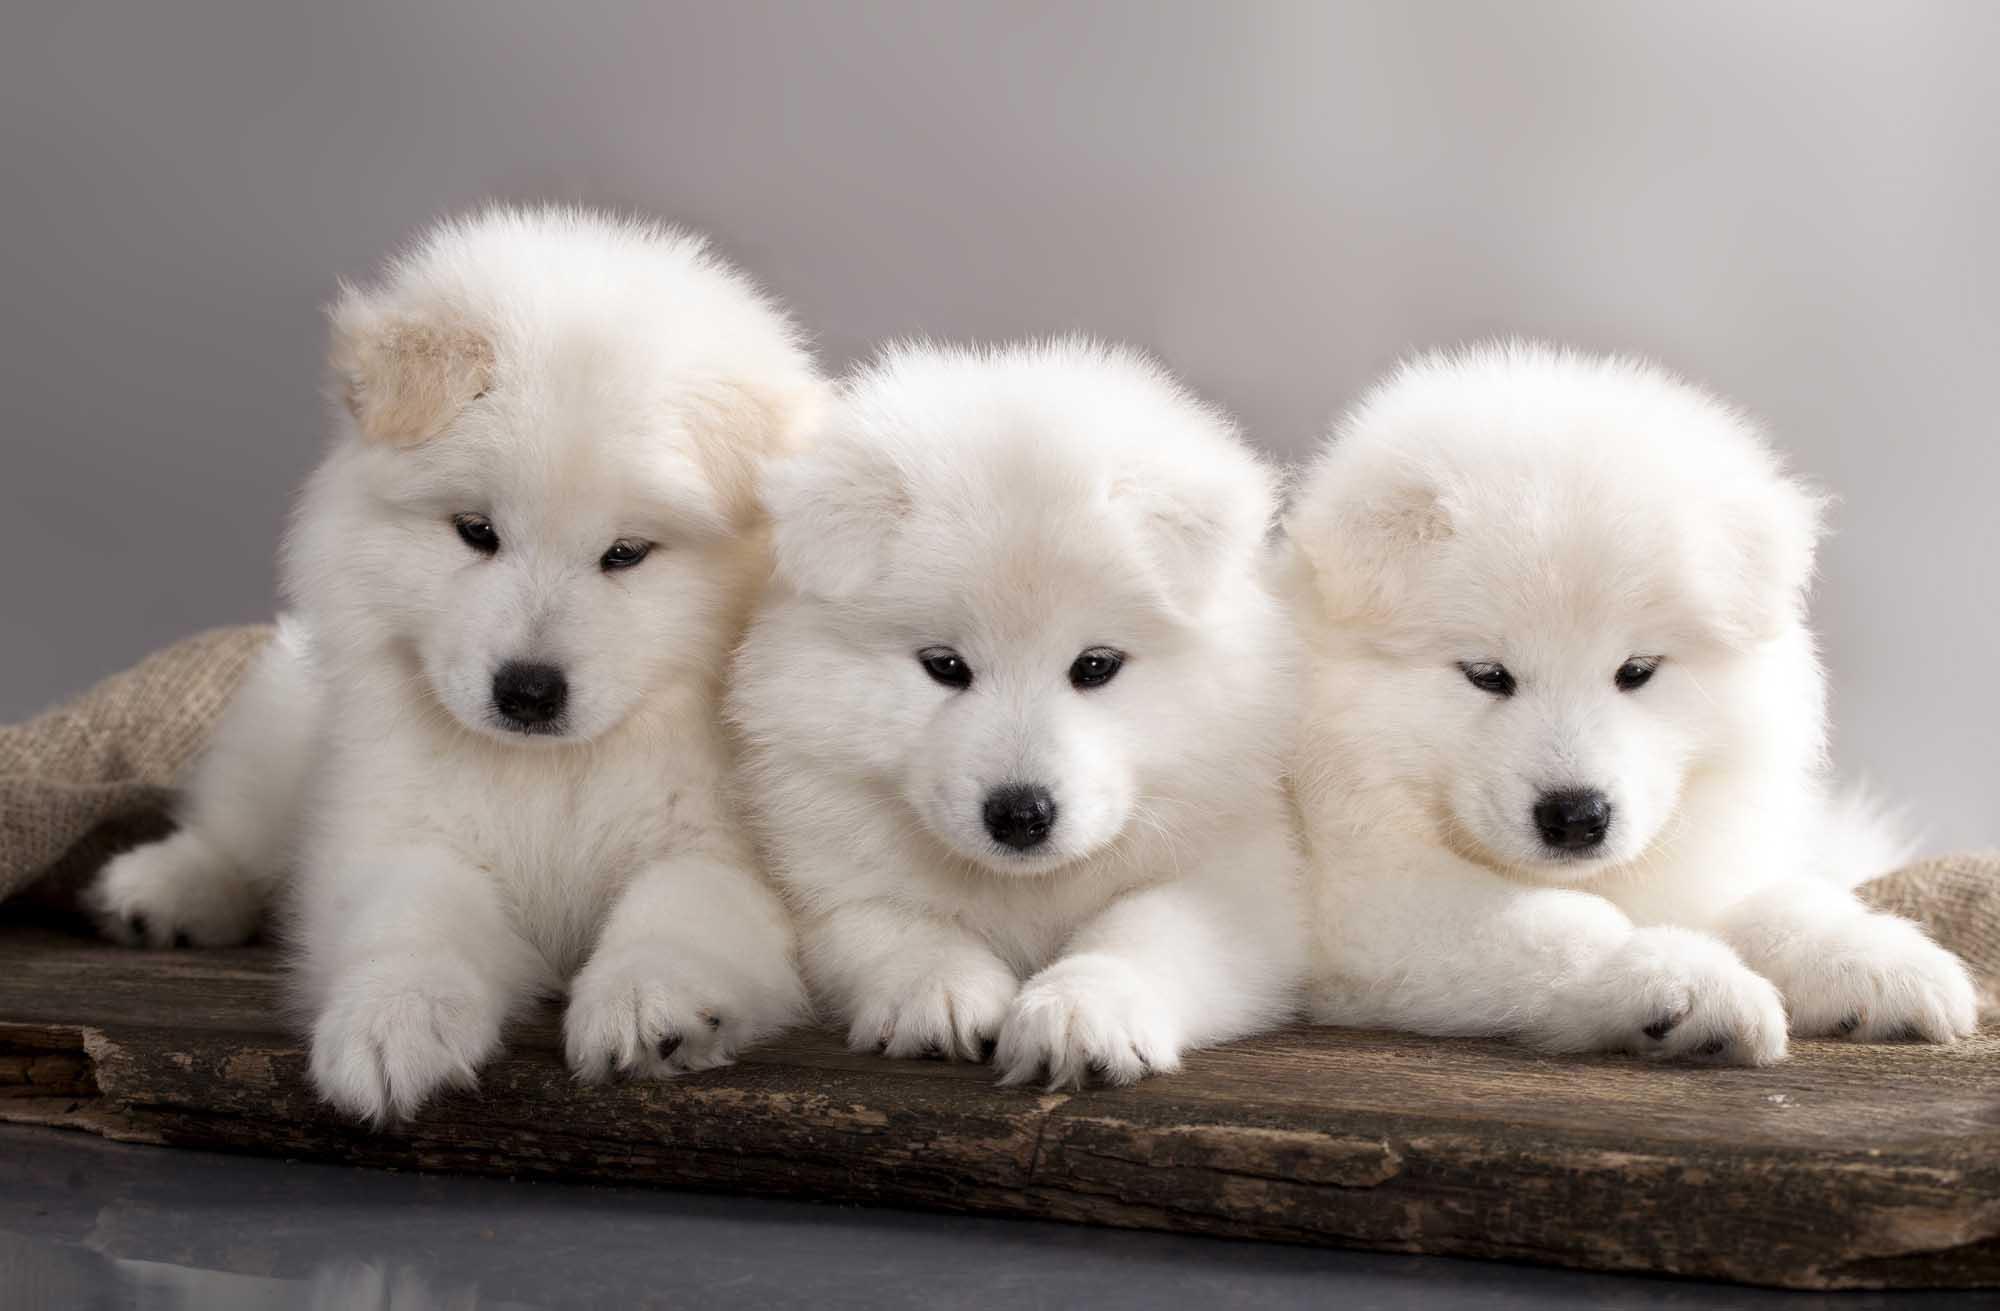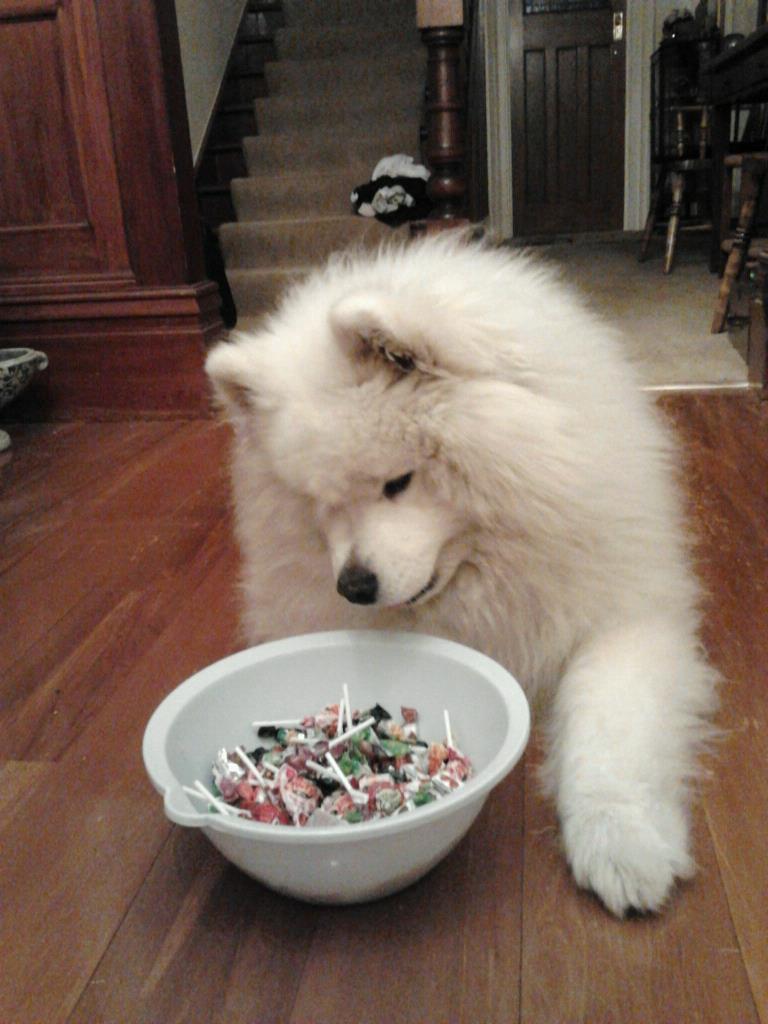The first image is the image on the left, the second image is the image on the right. For the images shown, is this caption "The leftmost image has a dog sitting in a chair, at a table with a plate or bowl and a cup in front of them." true? Answer yes or no. No. The first image is the image on the left, the second image is the image on the right. Analyze the images presented: Is the assertion "A puppy on a checkered blanket next to a picnic basket" valid? Answer yes or no. No. 